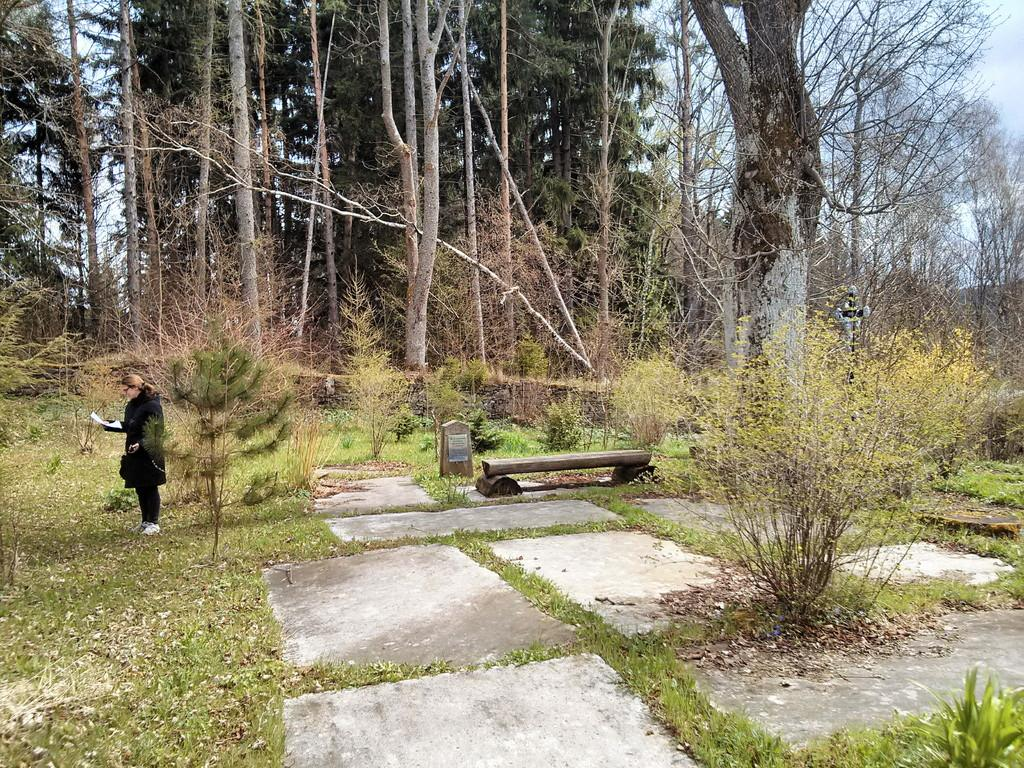Who is the main subject in the image? There is a girl in the image. Where is the girl located in the image? The girl is on the left side of the image. What is the girl holding in her hand? The girl is holding a paper in her hand. What can be seen in the center of the image? There is a log in the center of the image. What type of environment is depicted in the image? There is greenery around the image, suggesting a natural setting. What type of support can be seen in the image? There is no specific support structure visible in the image. What company is the girl representing in the image? The image does not provide any information about a company or the girl's affiliation. 